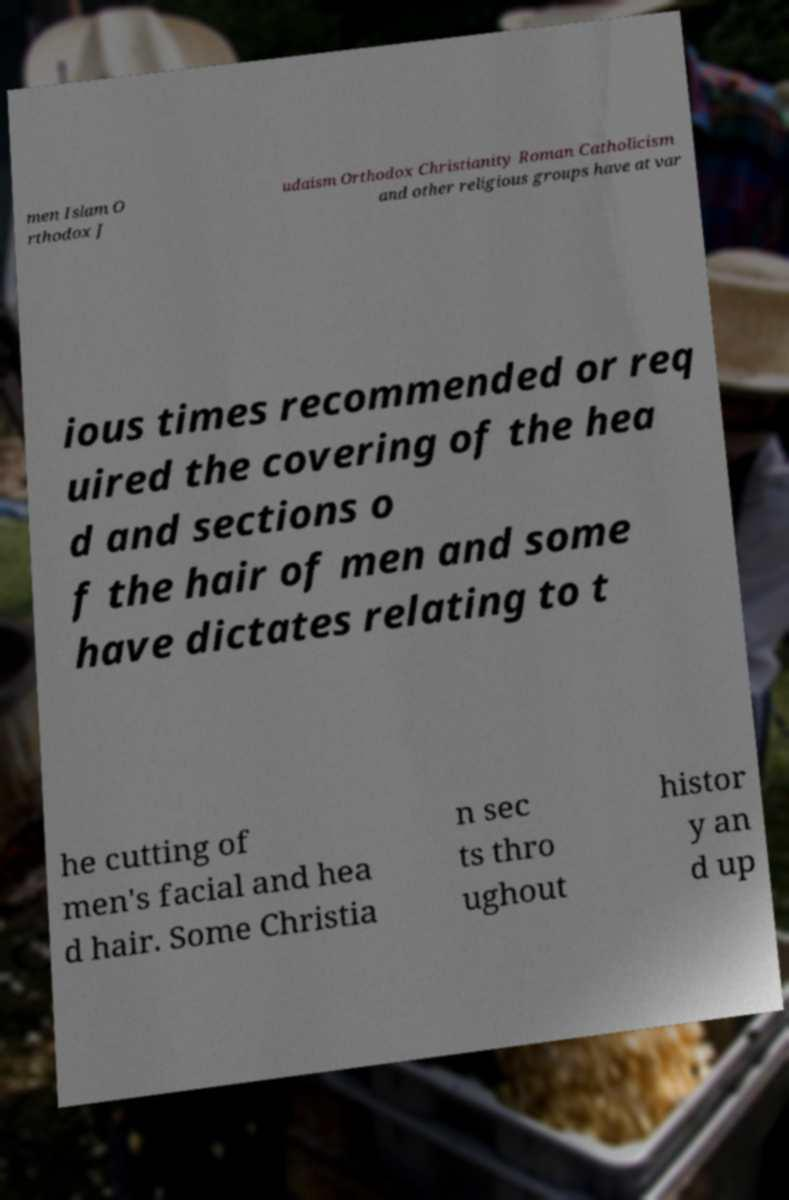Please read and relay the text visible in this image. What does it say? men Islam O rthodox J udaism Orthodox Christianity Roman Catholicism and other religious groups have at var ious times recommended or req uired the covering of the hea d and sections o f the hair of men and some have dictates relating to t he cutting of men's facial and hea d hair. Some Christia n sec ts thro ughout histor y an d up 